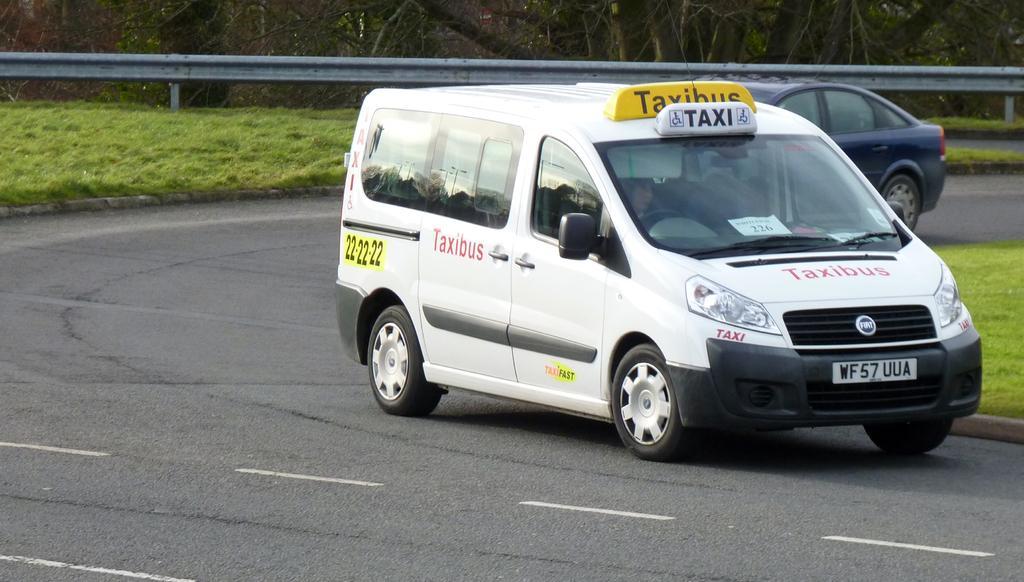In one or two sentences, can you explain what this image depicts? In this image I can see two vehicles on the road. In front the vehicle is in white color. In the background I can see the grass, few trees in green color and the iron fencing. 